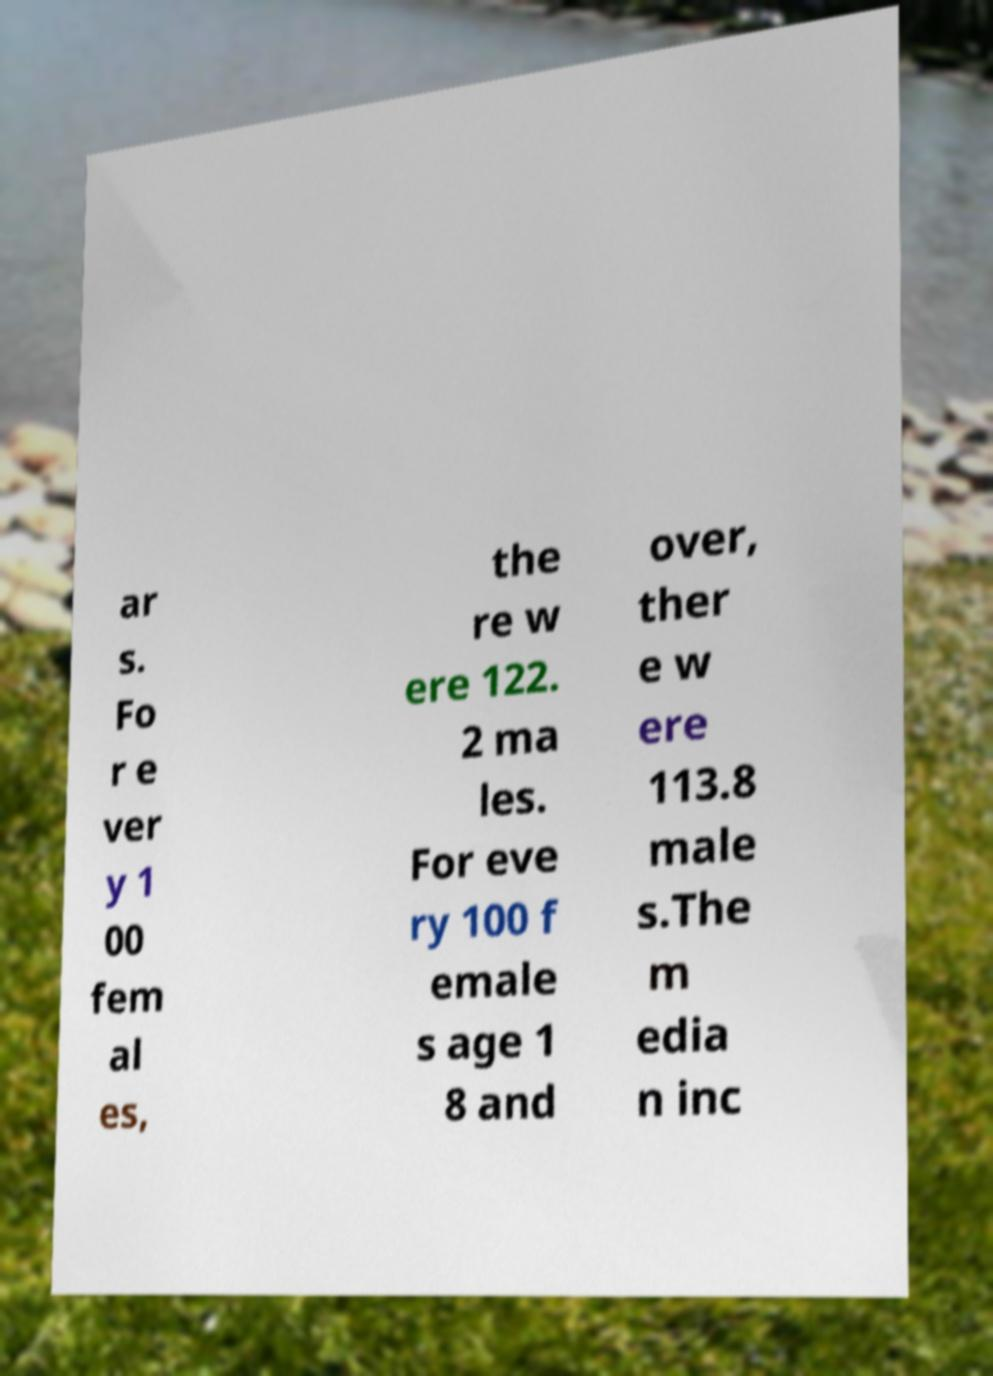Could you extract and type out the text from this image? ar s. Fo r e ver y 1 00 fem al es, the re w ere 122. 2 ma les. For eve ry 100 f emale s age 1 8 and over, ther e w ere 113.8 male s.The m edia n inc 